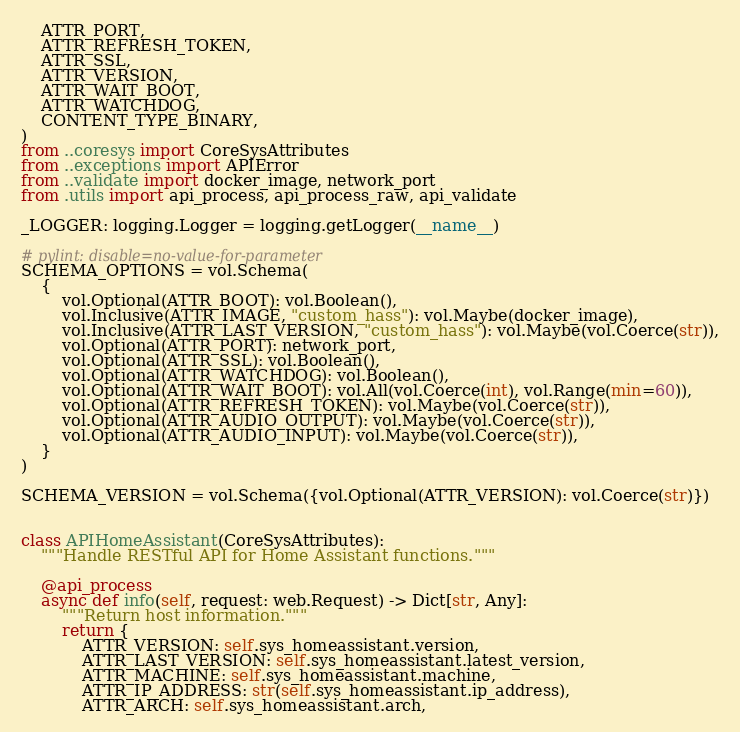<code> <loc_0><loc_0><loc_500><loc_500><_Python_>    ATTR_PORT,
    ATTR_REFRESH_TOKEN,
    ATTR_SSL,
    ATTR_VERSION,
    ATTR_WAIT_BOOT,
    ATTR_WATCHDOG,
    CONTENT_TYPE_BINARY,
)
from ..coresys import CoreSysAttributes
from ..exceptions import APIError
from ..validate import docker_image, network_port
from .utils import api_process, api_process_raw, api_validate

_LOGGER: logging.Logger = logging.getLogger(__name__)

# pylint: disable=no-value-for-parameter
SCHEMA_OPTIONS = vol.Schema(
    {
        vol.Optional(ATTR_BOOT): vol.Boolean(),
        vol.Inclusive(ATTR_IMAGE, "custom_hass"): vol.Maybe(docker_image),
        vol.Inclusive(ATTR_LAST_VERSION, "custom_hass"): vol.Maybe(vol.Coerce(str)),
        vol.Optional(ATTR_PORT): network_port,
        vol.Optional(ATTR_SSL): vol.Boolean(),
        vol.Optional(ATTR_WATCHDOG): vol.Boolean(),
        vol.Optional(ATTR_WAIT_BOOT): vol.All(vol.Coerce(int), vol.Range(min=60)),
        vol.Optional(ATTR_REFRESH_TOKEN): vol.Maybe(vol.Coerce(str)),
        vol.Optional(ATTR_AUDIO_OUTPUT): vol.Maybe(vol.Coerce(str)),
        vol.Optional(ATTR_AUDIO_INPUT): vol.Maybe(vol.Coerce(str)),
    }
)

SCHEMA_VERSION = vol.Schema({vol.Optional(ATTR_VERSION): vol.Coerce(str)})


class APIHomeAssistant(CoreSysAttributes):
    """Handle RESTful API for Home Assistant functions."""

    @api_process
    async def info(self, request: web.Request) -> Dict[str, Any]:
        """Return host information."""
        return {
            ATTR_VERSION: self.sys_homeassistant.version,
            ATTR_LAST_VERSION: self.sys_homeassistant.latest_version,
            ATTR_MACHINE: self.sys_homeassistant.machine,
            ATTR_IP_ADDRESS: str(self.sys_homeassistant.ip_address),
            ATTR_ARCH: self.sys_homeassistant.arch,</code> 